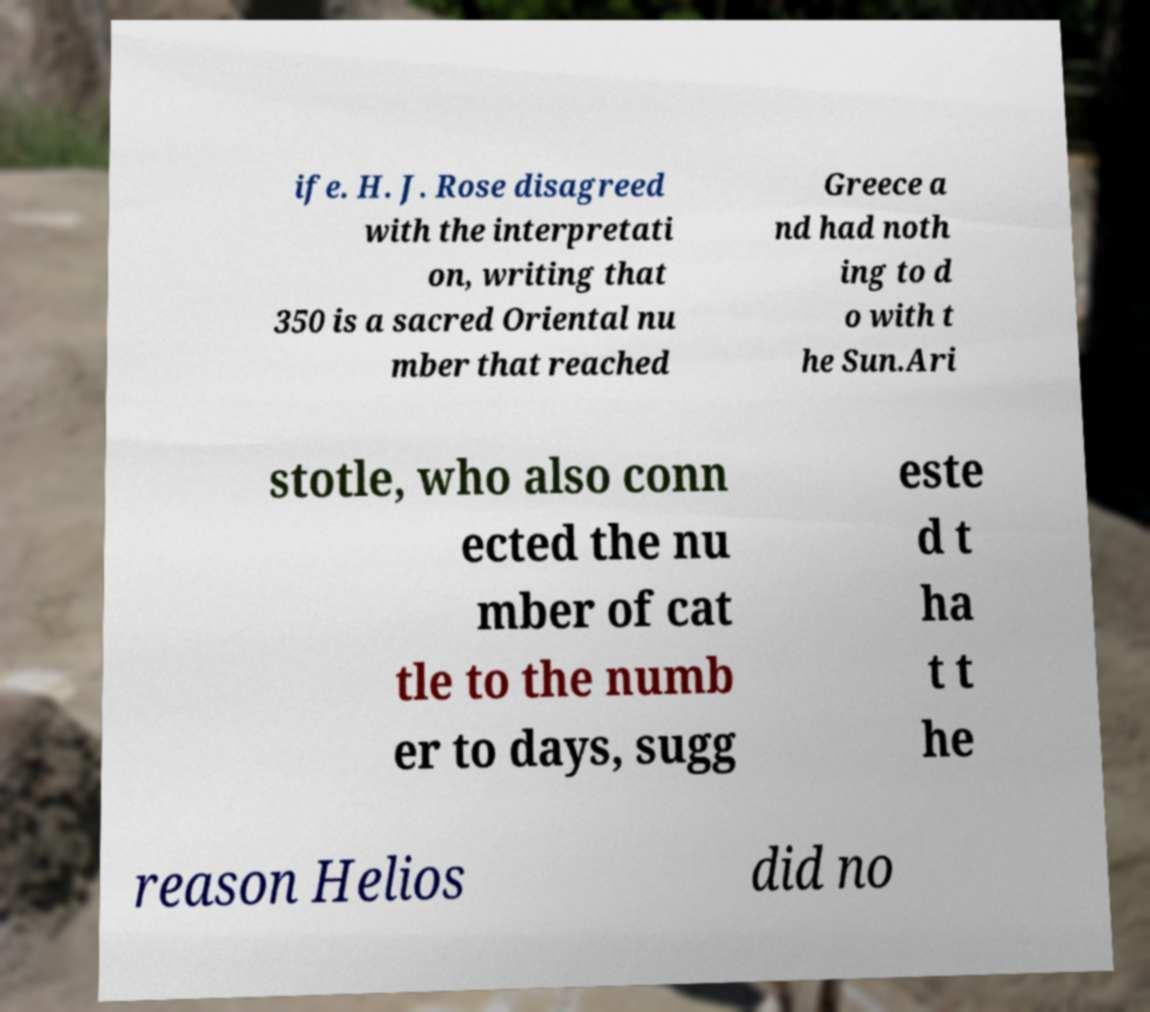I need the written content from this picture converted into text. Can you do that? ife. H. J. Rose disagreed with the interpretati on, writing that 350 is a sacred Oriental nu mber that reached Greece a nd had noth ing to d o with t he Sun.Ari stotle, who also conn ected the nu mber of cat tle to the numb er to days, sugg este d t ha t t he reason Helios did no 